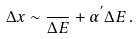Convert formula to latex. <formula><loc_0><loc_0><loc_500><loc_500>\Delta x \sim \frac { } { \Delta E } + \alpha ^ { ^ { \prime } } \Delta E \, .</formula> 